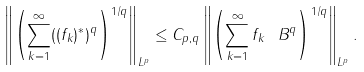Convert formula to latex. <formula><loc_0><loc_0><loc_500><loc_500>\left \| \left ( \sum _ { k = 1 } ^ { \infty } ( ( f _ { k } ) ^ { * } ) ^ { q } \right ) ^ { 1 / q } \right \| _ { L ^ { p } } \leq C _ { p , q } \left \| \left ( \sum _ { k = 1 } ^ { \infty } \| f _ { k } \| _ { \ } B ^ { q } \right ) ^ { 1 / q } \right \| _ { L ^ { p } } .</formula> 